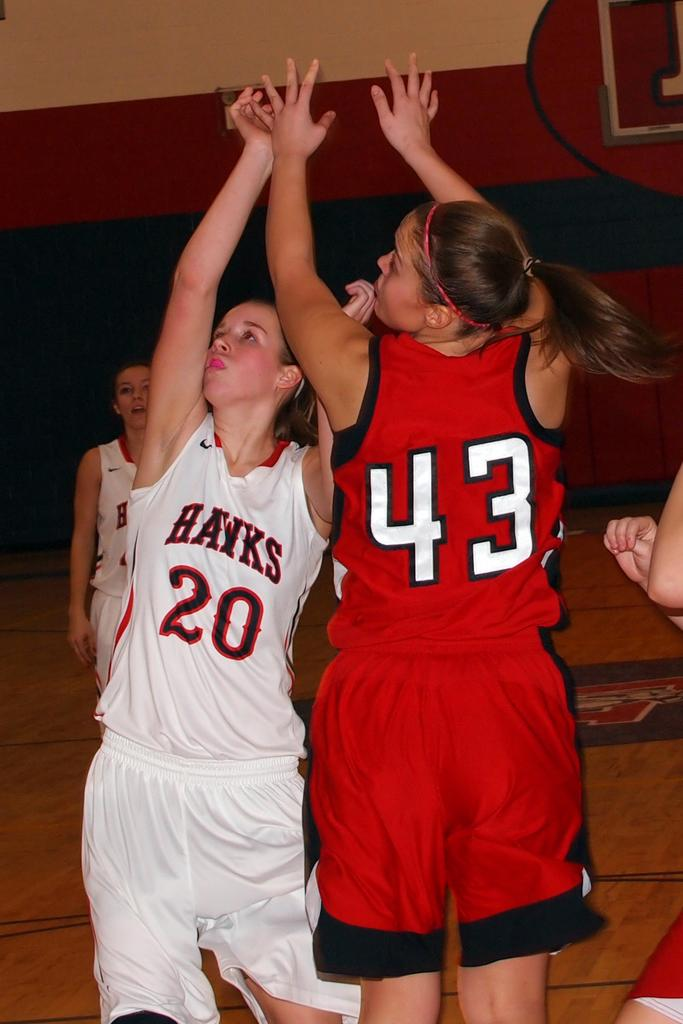<image>
Summarize the visual content of the image. Two women playing in a game of basketball. 